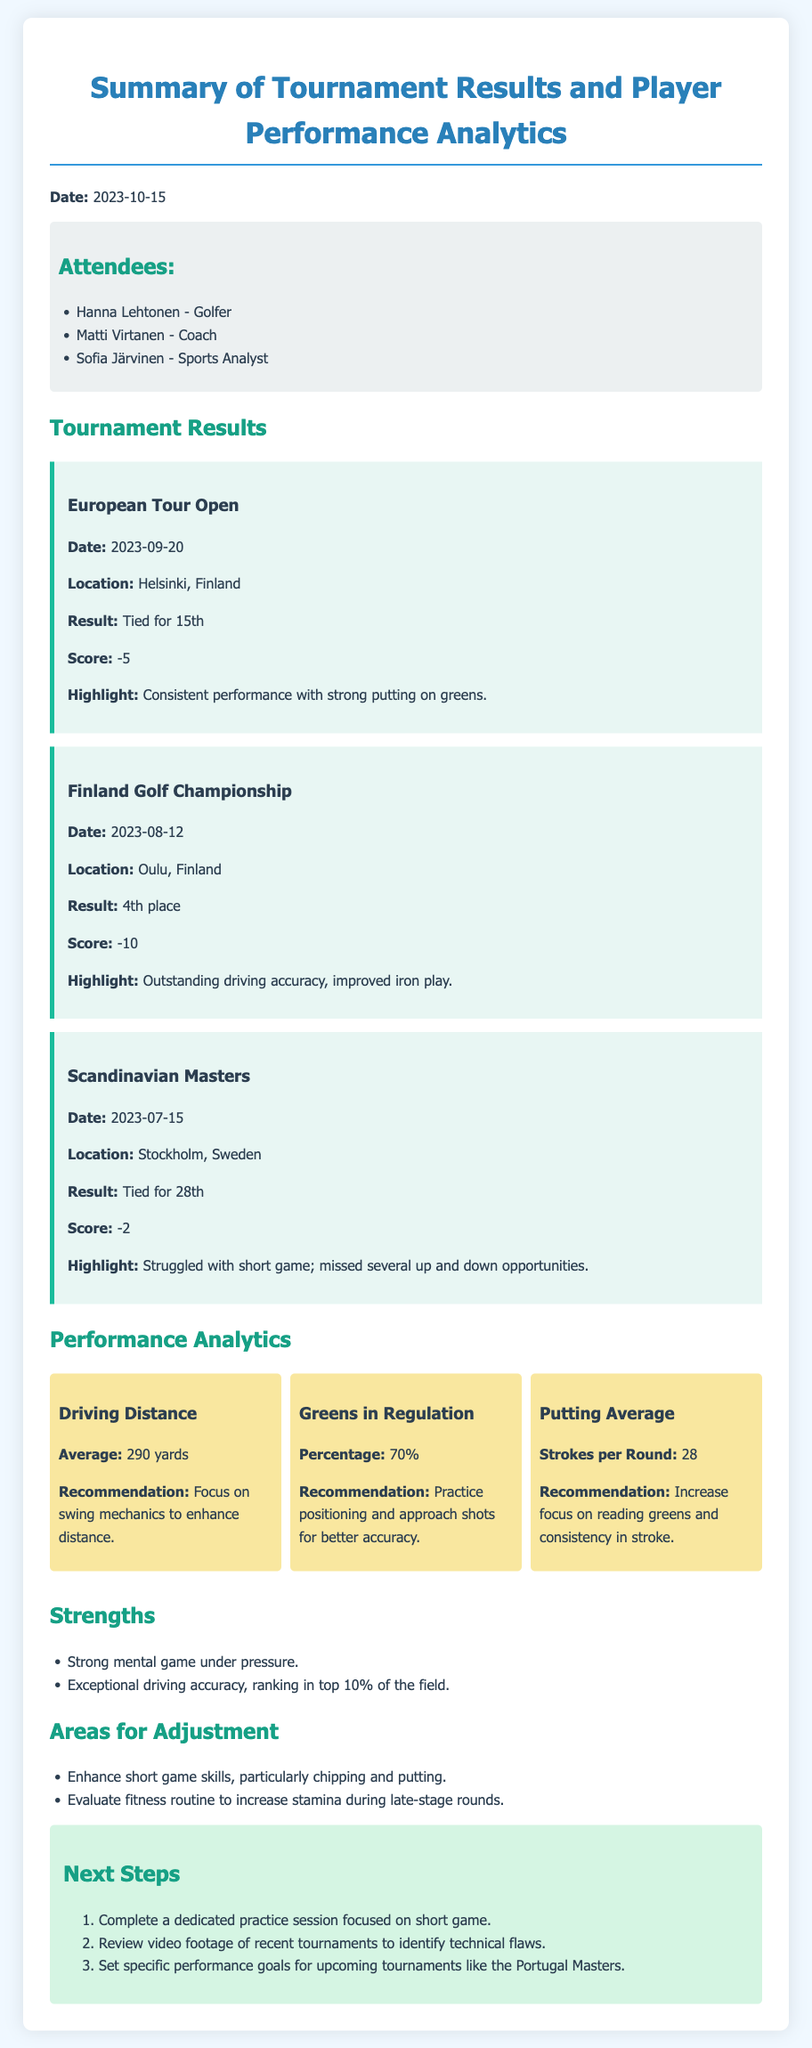What is the date of the meeting? The date of the meeting is explicitly stated in the document.
Answer: 2023-10-15 What was your result in the Finland Golf Championship? The Finland Golf Championship result is mentioned in the tournament results section, providing specific placement information.
Answer: 4th place How many strokes per round is your putting average? The putting average is recorded in the performance analytics section as strokes per round, giving a specific number.
Answer: 28 What was your score at the European Tour Open? The score at the European Tour Open is detailed under the tournament results, indicating performance during that event.
Answer: -5 What percentage of greens in regulation is noted? The percentage of greens in regulation is provided in the performance analytics and reflects accuracy during play.
Answer: 70% What is identified as an area for adjustment? Areas for adjustment is a section listing specific skills that require improvement based on performance.
Answer: Enhance short game skills Which tournament is mentioned as the next upcoming challenge? The next steps section includes specific tournaments that the player is preparing for, indicating future events.
Answer: Portugal Masters What was highlighted as a strength in performance? Strengths are listed outlining positive aspects of the player’s performance, capturing key advantages.
Answer: Strong mental game under pressure What is the average driving distance mentioned? The driving distance is specified in the performance analytics, reflecting a key metric for the player's game.
Answer: 290 yards 